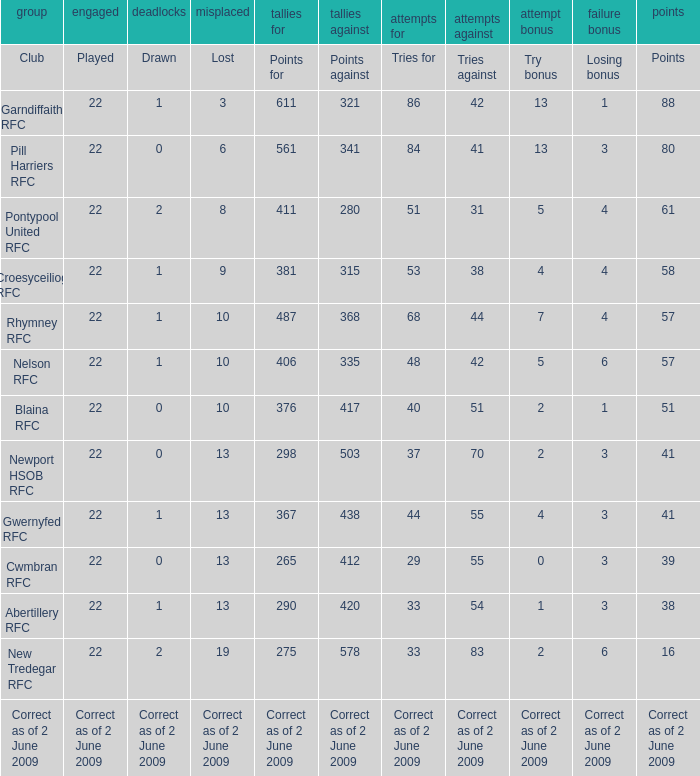How many tries did the club with a try bonus of correct as of 2 June 2009 have? Correct as of 2 June 2009. I'm looking to parse the entire table for insights. Could you assist me with that? {'header': ['group', 'engaged', 'deadlocks', 'misplaced', 'tallies for', 'tallies against', 'attempts for', 'attempts against', 'attempt bonus', 'failure bonus', 'points'], 'rows': [['Club', 'Played', 'Drawn', 'Lost', 'Points for', 'Points against', 'Tries for', 'Tries against', 'Try bonus', 'Losing bonus', 'Points'], ['Garndiffaith RFC', '22', '1', '3', '611', '321', '86', '42', '13', '1', '88'], ['Pill Harriers RFC', '22', '0', '6', '561', '341', '84', '41', '13', '3', '80'], ['Pontypool United RFC', '22', '2', '8', '411', '280', '51', '31', '5', '4', '61'], ['Croesyceiliog RFC', '22', '1', '9', '381', '315', '53', '38', '4', '4', '58'], ['Rhymney RFC', '22', '1', '10', '487', '368', '68', '44', '7', '4', '57'], ['Nelson RFC', '22', '1', '10', '406', '335', '48', '42', '5', '6', '57'], ['Blaina RFC', '22', '0', '10', '376', '417', '40', '51', '2', '1', '51'], ['Newport HSOB RFC', '22', '0', '13', '298', '503', '37', '70', '2', '3', '41'], ['Gwernyfed RFC', '22', '1', '13', '367', '438', '44', '55', '4', '3', '41'], ['Cwmbran RFC', '22', '0', '13', '265', '412', '29', '55', '0', '3', '39'], ['Abertillery RFC', '22', '1', '13', '290', '420', '33', '54', '1', '3', '38'], ['New Tredegar RFC', '22', '2', '19', '275', '578', '33', '83', '2', '6', '16'], ['Correct as of 2 June 2009', 'Correct as of 2 June 2009', 'Correct as of 2 June 2009', 'Correct as of 2 June 2009', 'Correct as of 2 June 2009', 'Correct as of 2 June 2009', 'Correct as of 2 June 2009', 'Correct as of 2 June 2009', 'Correct as of 2 June 2009', 'Correct as of 2 June 2009', 'Correct as of 2 June 2009']]} 